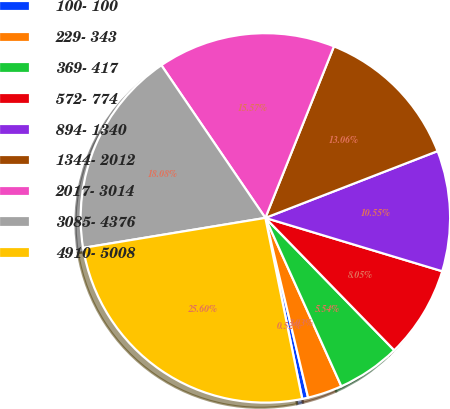Convert chart to OTSL. <chart><loc_0><loc_0><loc_500><loc_500><pie_chart><fcel>100- 100<fcel>229- 343<fcel>369- 417<fcel>572- 774<fcel>894- 1340<fcel>1344- 2012<fcel>2017- 3014<fcel>3085- 4376<fcel>4910- 5008<nl><fcel>0.52%<fcel>3.03%<fcel>5.54%<fcel>8.05%<fcel>10.55%<fcel>13.06%<fcel>15.57%<fcel>18.08%<fcel>25.6%<nl></chart> 